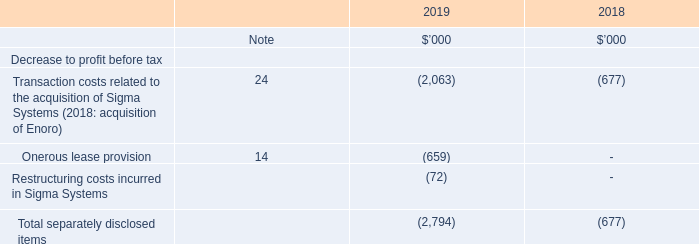4. SEPARATELY DISCLOSED ITEMS
The Group has disclosed underlying EBITDA1 and underlying profit after tax, referring to the Group’s trading results adjusted for certain transactions during the year that are not representative of the Group’s regular business activities. The Group considers that these transactions are of such significance to understanding the ongoing results of the Group that the Group has elected to separately identify these transactions to determine an ongoing result to enable a 'like-for-like' comparison. These items are described as 'separately disclosed items' throughout this Financial Report.
Transaction costs related to the acquisition of Sigma Systems (2018: acquisition of Enoro)
Transaction costs of $2,063,000 were incurred in relation to the acquisition of the Sigma Systems group of entities (Sigma). These include costs associated with vendor due diligence, legal and other administrative matters, as well as related travel costs incurred to meet representatives of Sigma’s management. These costs are included with 'Travel Expenses' and 'Other Expenses' in the Group’s consolidated statement of comprehensive income.
Further details of the acquisition of Sigma are described in Note 24.
In the prior year, transaction costs of $677,000 were incurred in relation to the acquisition of Enoro Holdings AS (subsequently renamed to Hansen Technologies Holdings AS during FY19) and its controlled subsidiaries. These costs were included with 'Other Expenses' in the Group’s consolidated statement of comprehensive income in the prior year.
Onerous lease provision
The Group recognised a provision on future lease payments for one of our offices in the Americas, as the non-cancellable future payments in the lease contract are expected to exceed the benefits from keeping the office over the remainder of the lease term. The Group has separately identified these costs because it is not in the normal course of business activities. These costs are included with 'Property and Operating Rental Expenses' in the Group’s consolidated statement of comprehensive income.
Restructuring costs incurred in Sigma Systems
Included in Sigma’s results for June are $72,000 of restructuring costs related to certain redundancy payments post-acquisition. These costs are included with 'Employee Benefit Expenses' in the Group’s consolidated statement of comprehensive income.
How much transaction cost was incurred to acquire Sigma Systems group of entities? $2,063,000. What was the transaction costs in 2018 comprised of? The acquisition of enoro holdings as (subsequently renamed to hansen technologies holdings as during fy19) and its controlled subsidiaries. How much restructuring costs was incurred after acquisition of Sigma Systems? $72,000. What was the average transaction costs related to the acquisitions for both years?
Answer scale should be: thousand. (2,063 + 677) / 2 
Answer: 1370. What was the Transaction and restructuring costs incurred by the acquisition of Sigma Systems?
Answer scale should be: thousand. 2,063 + 72 
Answer: 2135. What was the difference in transaction costs between the acquisition of Enoro in 2018 and acquisition of Sigma Systems in 2019?
Answer scale should be: thousand. 2,063 - 677 
Answer: 1386. 